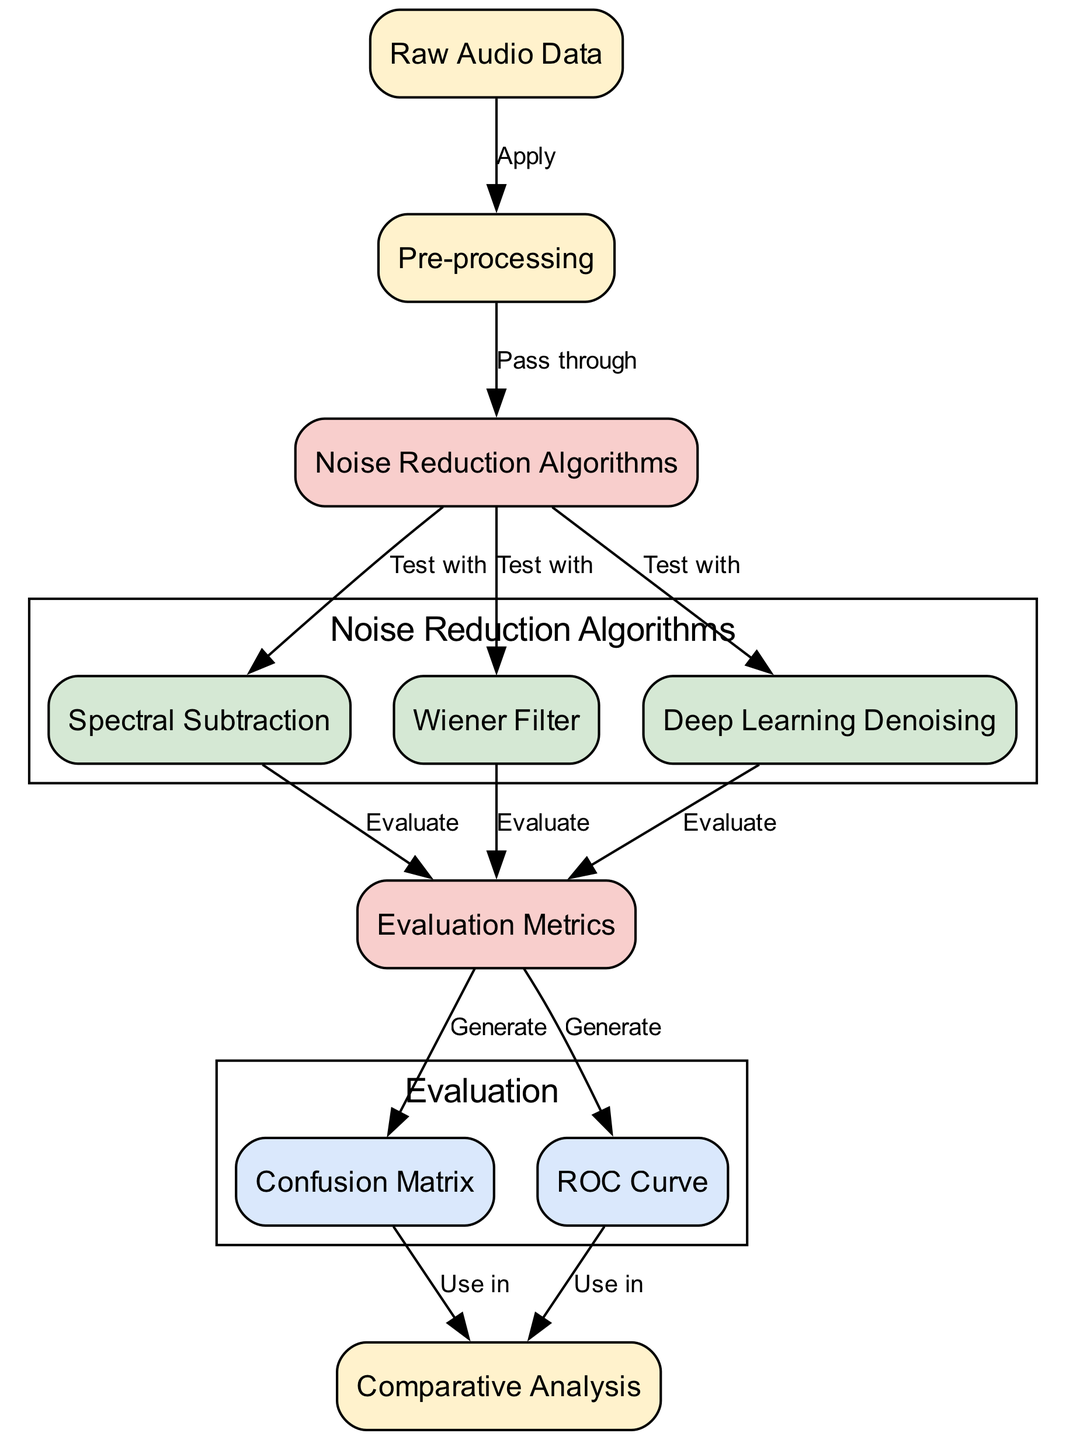What is the first node in the diagram? The diagram begins with the node labeled "Raw Audio Data". This can be identified as it is the first node leading to the preprocessing step.
Answer: Raw Audio Data How many noise reduction algorithms are tested? There are three noise reduction algorithms represented in the diagram: Spectral Subtraction, Wiener Filter, and Deep Learning Denoising. This is counted by identifying the edges that connect from the "Noise Reduction Algorithms" node to each of the three algorithm nodes.
Answer: Three What are the two evaluation metrics generated after evaluating the noise reduction algorithms? The evaluation metrics generated after evaluating the algorithms are the Confusion Matrix and the ROC Curve. This can be seen directly from the edges leading from the "Evaluation Metrics" node to the respective metric nodes.
Answer: Confusion Matrix and ROC Curve What step occurs after pre-processing the raw audio data? After pre-processing, the processed data passes through the "Noise Reduction Algorithms" node, indicating the transition to noise reduction techniques. This is confirmed by the edge leading from the "Pre-processing" node to the "Noise Reduction Algorithms" node.
Answer: Pass through Which node uses the confusion matrix in its process? The "Comparative Analysis" node uses the confusion matrix, as indicated by the edge leading from the "Confusion Matrix" node to the "Comparative Analysis" node. This is a direct representation of the utilization of the confusion matrix.
Answer: Comparative Analysis How many evaluation metrics are generated from the evaluation of the noise reduction algorithms? Two evaluation metrics are generated from the evaluation process, which include the Confusion Matrix and ROC Curve. This is evident by the edges connecting from "Evaluation Metrics" to each of these metrics' nodes.
Answer: Two What flows into the evaluation metrics after testing the noise reduction algorithms? The evaluation metrics receive input from the evaluations of the noise reduction algorithms (Spectral Subtraction, Wiener Filter, Deep Learning Denoising), signifying their importance in assessing the performance. This can be deduced from the edges going from each algorithm to "Evaluation Metrics".
Answer: Noise Reduction Algorithms Which node is positioned last in the flow after generating evaluation metrics? The last node in the flow after generating evaluation metrics is the "Comparative Analysis" node. This can be traced from "Confusion Matrix" and "ROC Curve" both feeding into the "Comparative Analysis".
Answer: Comparative Analysis 